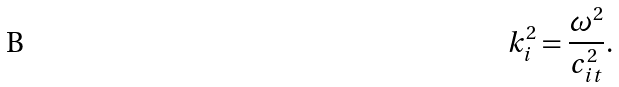<formula> <loc_0><loc_0><loc_500><loc_500>k _ { i } ^ { 2 } = \frac { \omega ^ { 2 } } { c _ { i t } ^ { 2 } } .</formula> 